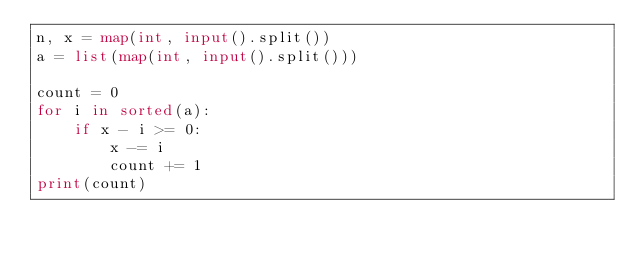<code> <loc_0><loc_0><loc_500><loc_500><_Python_>n, x = map(int, input().split())
a = list(map(int, input().split()))

count = 0
for i in sorted(a):
    if x - i >= 0:
        x -= i
        count += 1
print(count)
</code> 